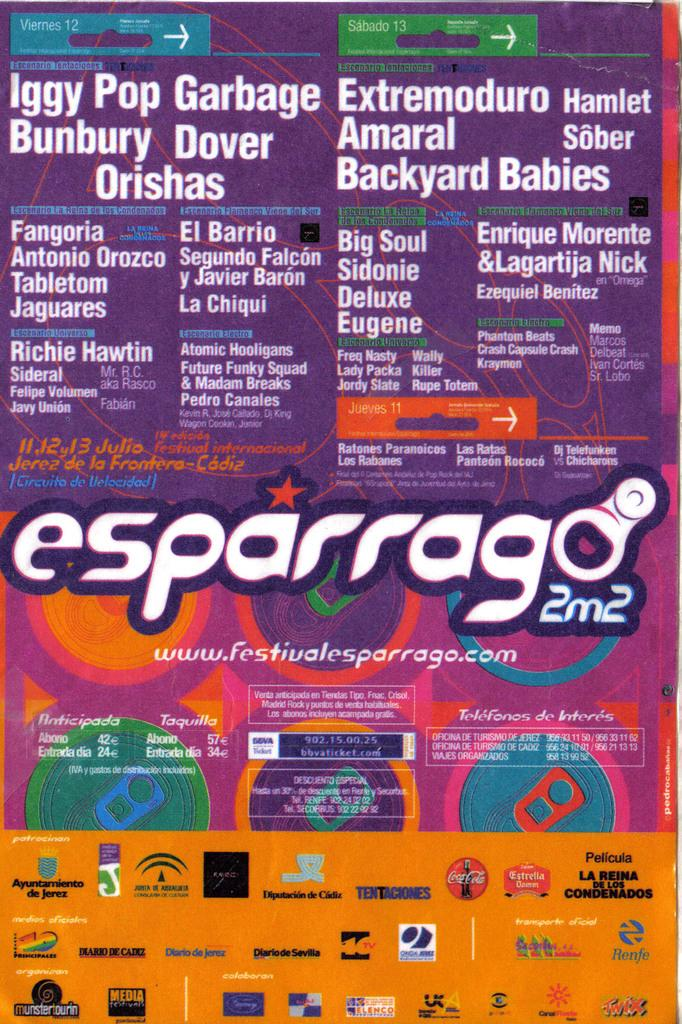<image>
Describe the image concisely. Posterfor Iggy Pop Garbage that has a Coca Cola logo on the bottom. 